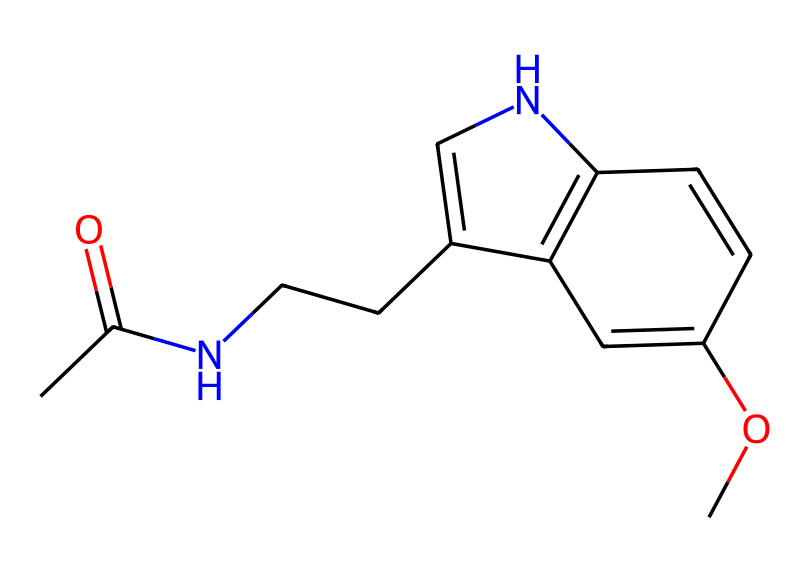How many carbon atoms are present in melatonin? Count the number of "C" symbols in the SMILES representation. The SMILES provided contains a total of 13 carbon atoms.
Answer: 13 What is the functional group present in melatonin that characterizes it as an amide? The presence of the carbonyl (C=O) adjacent to a nitrogen (N) indicates that melatonin contains an amide functional group. This is seen in the "CC(=O)N" section of the SMILES.
Answer: amide How many rings are present in the structure of melatonin? By analyzing the SMILES structure, you can see the closed cycles indicated by "C1=C" and "C2=C1". There are a total of 2 rings in the structure.
Answer: 2 What type of biological function is primarily associated with melatonin? Melatonin is mainly known for its role in the regulation of sleep, as it is produced in response to darkness, signaling the body to prepare for sleep.
Answer: sleep regulation What is the relationship between melatonin and its role in the circadian rhythm? Melatonin helps regulate the body's circadian rhythm by signaling the transition from day to night, which affects physiological processes such as sleep-wake cycles. This is due to its production being influenced by light exposure.
Answer: circadian rhythm What additional functional group is present in melatonin that contributes to its hydrophilicity? The methoxy group (-OCH3) present in the structure provides hydrophilicity, increasing melatonin's solubility in water compared to purely hydrophobic structures. This is identified in the "C(OC)" part of the SMILES.
Answer: methoxy group 